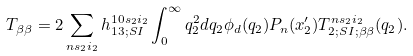Convert formula to latex. <formula><loc_0><loc_0><loc_500><loc_500>T _ { \beta \beta } = 2 \sum _ { n s _ { 2 } i _ { 2 } } h _ { 1 3 ; S I } ^ { 1 0 s _ { 2 } i _ { 2 } } \int _ { 0 } ^ { \infty } q _ { 2 } ^ { 2 } d q _ { 2 } \phi _ { d } ( q _ { 2 } ) P _ { n } ( x _ { 2 } ^ { \prime } ) T _ { 2 ; S I ; \beta \beta } ^ { n s _ { 2 } i _ { 2 } } ( q _ { 2 } ) .</formula> 